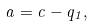<formula> <loc_0><loc_0><loc_500><loc_500>a = c - q _ { 1 } ,</formula> 